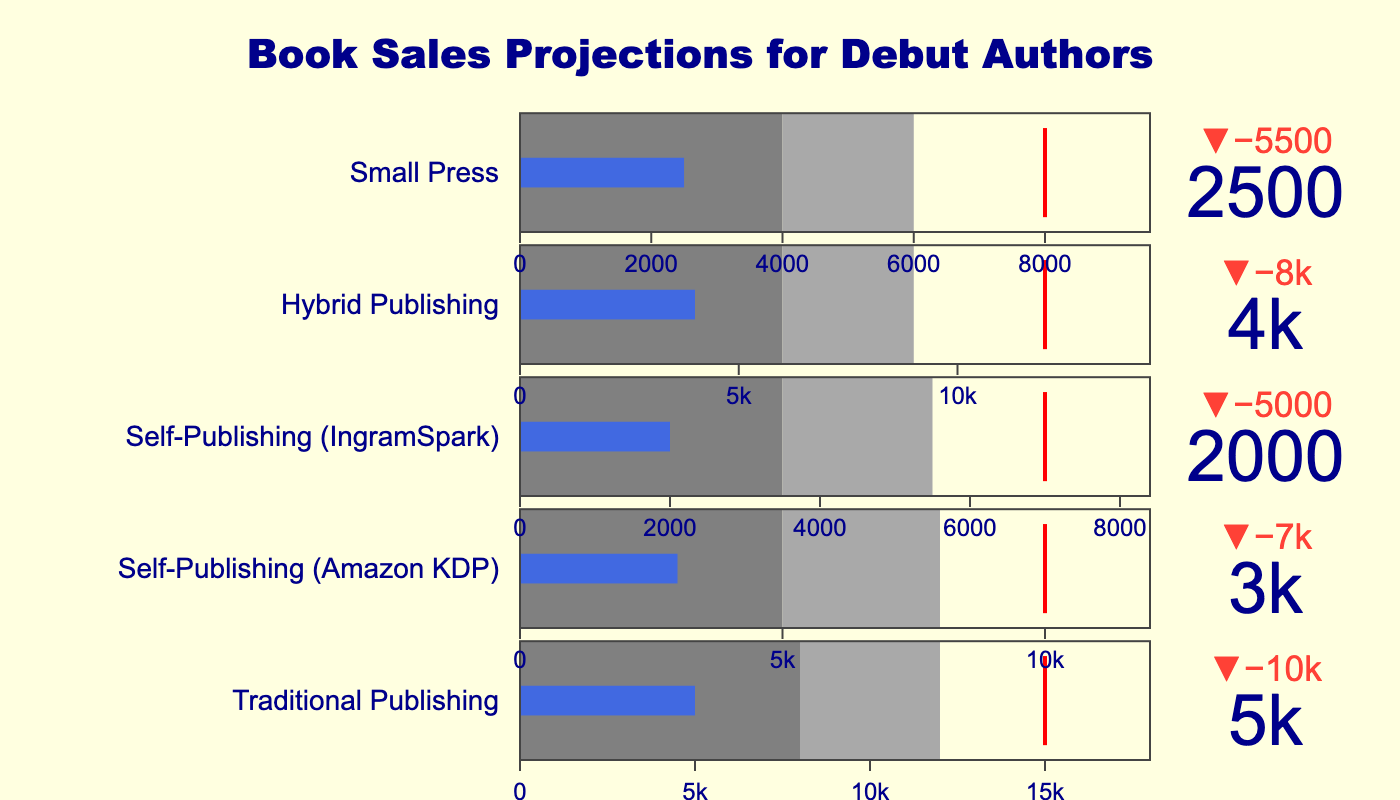What's the title of the figure? The title of the figure is located at the top of the chart. It reads "Book Sales Projections for Debut Authors".
Answer: Book Sales Projections for Debut Authors Which publishing route has the highest actual book sales? By examining the actual sales values for each category in the figure, the "Traditional Publishing" route shows the highest sales with 5,000 books.
Answer: Traditional Publishing What is the target book sales for Self-Publishing (Amazon KDP)? Looking at the target values displayed in the figure, the target for Self-Publishing (Amazon KDP) is 10,000 books.
Answer: 10,000 Compare the actual sales with the target sales for Hybrid Publishing. Are the actual sales above or below the target? For Hybrid Publishing, the actual sales are 4,000 books and the target is 12,000 books. The actual sales are below the target.
Answer: Below What's the difference between the actual and target sales for Small Press? The actual sales for Small Press are 2,500 books, whereas the target is 8,000 books. The difference is 8,000 - 2,500 = 5,500 books.
Answer: 5,500 Which self-publishing method has the lowest actual book sales? Comparing the actual sales for the self-publishing methods, IngramSpark has the lowest at 2,000 books.
Answer: IngramSpark What is the range of the most successful sales outcomes for Traditional Publishing? The darkest gray area in the Traditional Publishing indicator represents the most successful sales outcomes, which range from 8,000 to 12,000 books.
Answer: 8,000 to 12,000 How does the actual sales performance of Self-Publishing (Amazon KDP) compare to its target in terms of percentage? The actual sales for Self-Publishing (Amazon KDP) are 3,000 books, and the target is 10,000 books. 3,000 / 10,000 * 100 = 30%. Therefore, it has achieved 30% of its target.
Answer: 30% What is the color used to indicate the actual sales bar across all categories? In each category of the figure, the actual sales bar is consistently colored in royal blue.
Answer: Royal blue Which category has the closest actual sales to its target? Comparing the actual sales to the target across all categories, Traditional Publishing has the closest ratio, with actual sales of 5,000 books against a target of 15,000 books.
Answer: Traditional Publishing 